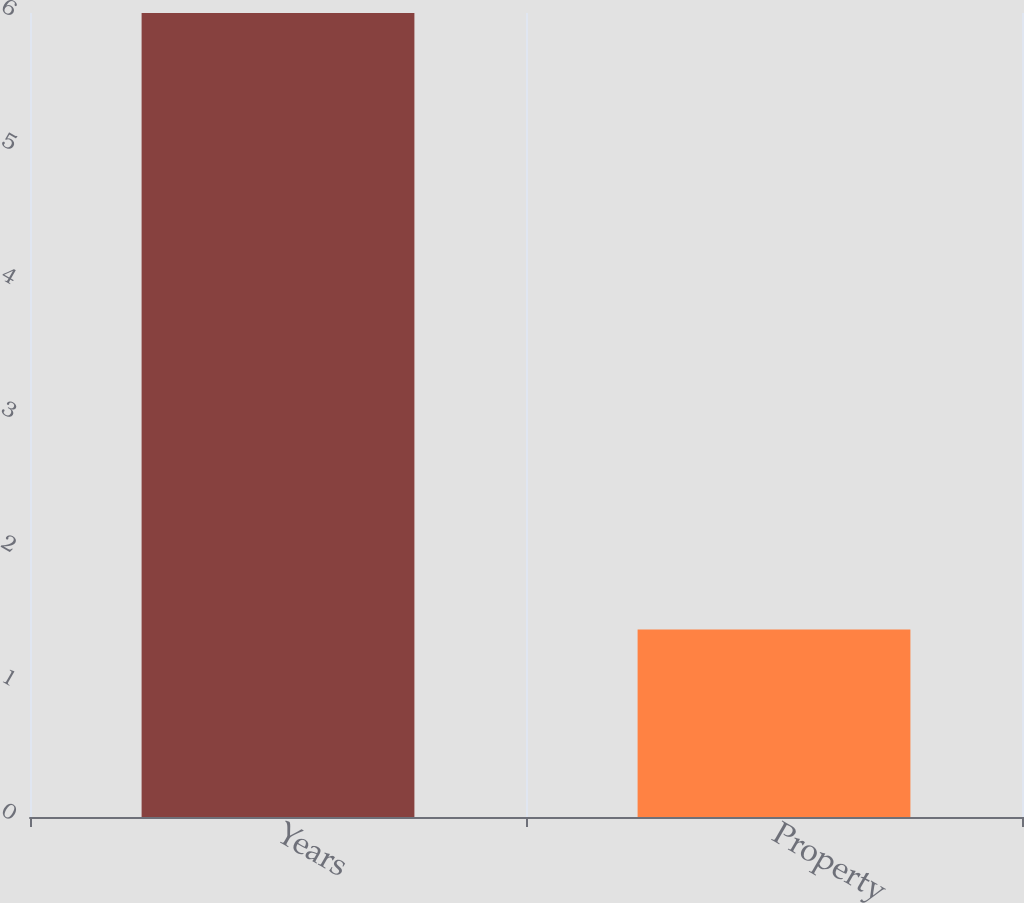<chart> <loc_0><loc_0><loc_500><loc_500><bar_chart><fcel>Years<fcel>Property<nl><fcel>6<fcel>1.4<nl></chart> 